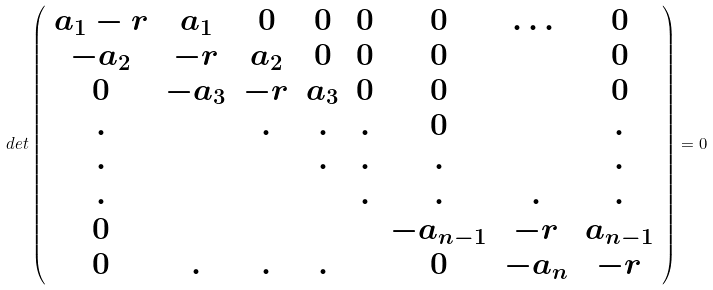<formula> <loc_0><loc_0><loc_500><loc_500>d e t \left ( \begin{array} { c c c c c c c c } a _ { 1 } - r & a _ { 1 } & 0 & 0 & 0 & 0 & \dots & 0 \\ - a _ { 2 } & - r & a _ { 2 } & 0 & 0 & 0 & & 0 \\ 0 & - a _ { 3 } & - r & a _ { 3 } & 0 & 0 & & 0 \\ . & & . & . & . & 0 & & . \\ . & & & . & . & . & & . \\ . & & & & . & . & . & . \\ 0 & & & & & - a _ { n - 1 } & - r & a _ { n - 1 } \\ 0 & . & . & . & & 0 & - a _ { n } & - r \\ \end{array} \right ) = 0</formula> 